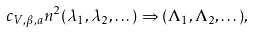Convert formula to latex. <formula><loc_0><loc_0><loc_500><loc_500>c _ { V , \beta , a } n ^ { 2 } ( \lambda _ { 1 } , \lambda _ { 2 } , \dots ) \Rightarrow ( \Lambda _ { 1 } , \Lambda _ { 2 } , \dots ) ,</formula> 